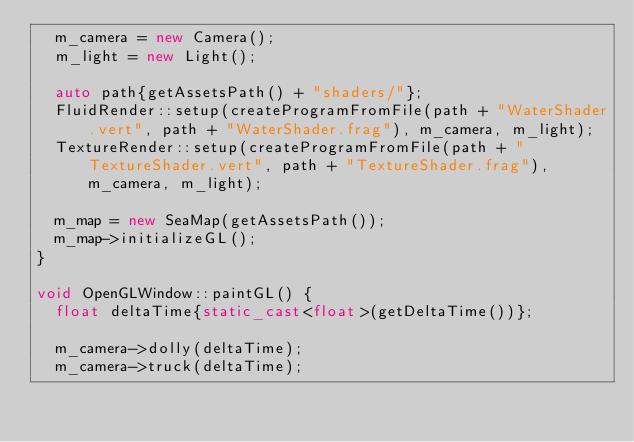<code> <loc_0><loc_0><loc_500><loc_500><_C++_>	m_camera = new Camera();
	m_light = new Light();

	auto path{getAssetsPath() + "shaders/"};
	FluidRender::setup(createProgramFromFile(path + "WaterShader.vert", path + "WaterShader.frag"), m_camera, m_light);
	TextureRender::setup(createProgramFromFile(path + "TextureShader.vert", path + "TextureShader.frag"), m_camera, m_light);

	m_map = new SeaMap(getAssetsPath());
	m_map->initializeGL();
}

void OpenGLWindow::paintGL() {
	float deltaTime{static_cast<float>(getDeltaTime())};

	m_camera->dolly(deltaTime);
	m_camera->truck(deltaTime);</code> 